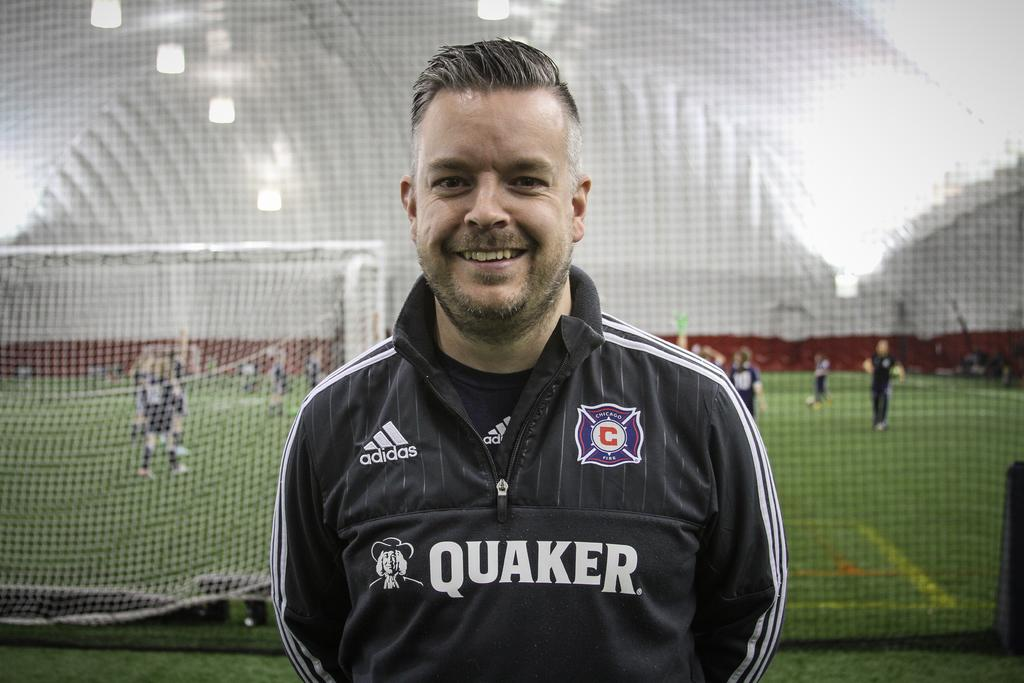What is the man in the image doing? The man is standing in the image and smiling. What can be seen in the background of the image? There is a sports ground, a sportsnet, walls, and persons standing on the ground in the background of the image. Can you describe the setting of the image? The image appears to be taken at a sports facility, with a sports ground and sportsnet visible in the background. What type of straw is being used to build a sandcastle on the moon in the image? There is no straw, sandcastle, or moon present in the image. 